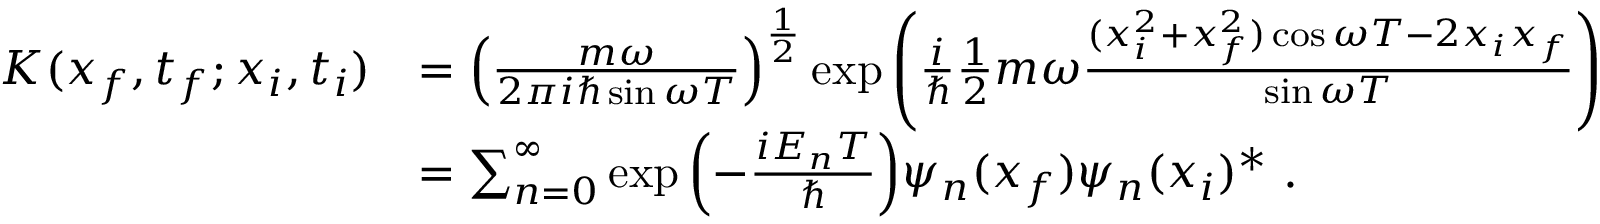<formula> <loc_0><loc_0><loc_500><loc_500>{ \begin{array} { r l } { K ( x _ { f } , t _ { f } ; x _ { i } , t _ { i } ) } & { = \left ( { \frac { m \omega } { 2 \pi i \hbar { \sin } \omega T } } \right ) ^ { \frac { 1 } { 2 } } \exp { \left ( { \frac { i } { } } { \frac { 1 } { 2 } } m \omega { \frac { ( x _ { i } ^ { 2 } + x _ { f } ^ { 2 } ) \cos \omega T - 2 x _ { i } x _ { f } } { \sin \omega T } } \right ) } } \\ & { = \sum _ { n = 0 } ^ { \infty } \exp { \left ( - { \frac { i E _ { n } T } { } } \right ) } \psi _ { n } ( x _ { f } ) \psi _ { n } ( x _ { i } ) ^ { * } . } \end{array} }</formula> 